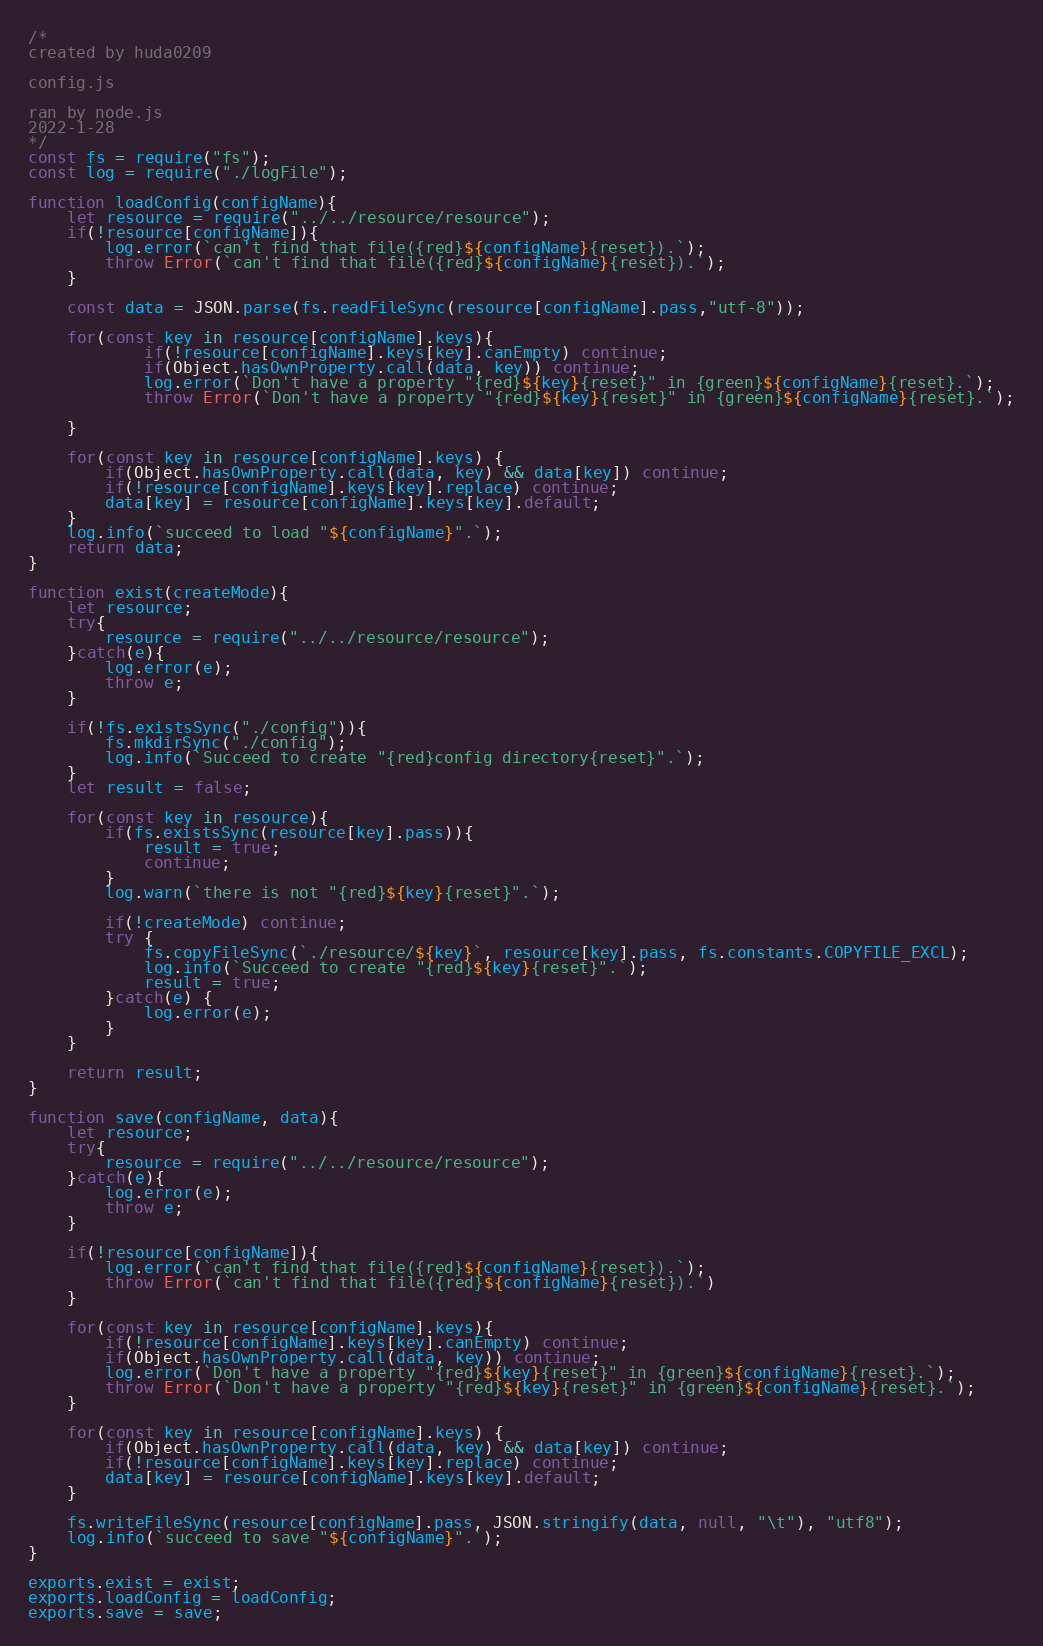Convert code to text. <code><loc_0><loc_0><loc_500><loc_500><_JavaScript_>/*
created by huda0209

config.js
 
ran by node.js
2022-1-28
*/
const fs = require("fs");
const log = require("./logFile");

function loadConfig(configName){
    let resource = require("../../resource/resource");
    if(!resource[configName]){
        log.error(`can't find that file({red}${configName}{reset}).`);
        throw Error(`can't find that file({red}${configName}{reset}).`);
    }

    const data = JSON.parse(fs.readFileSync(resource[configName].pass,"utf-8"));

    for(const key in resource[configName].keys){
            if(!resource[configName].keys[key].canEmpty) continue;
            if(Object.hasOwnProperty.call(data, key)) continue;
            log.error(`Don't have a property "{red}${key}{reset}" in {green}${configName}{reset}.`);
            throw Error(`Don't have a property "{red}${key}{reset}" in {green}${configName}{reset}.`);
        
    }

    for(const key in resource[configName].keys) {
        if(Object.hasOwnProperty.call(data, key) && data[key]) continue;
        if(!resource[configName].keys[key].replace) continue;
        data[key] = resource[configName].keys[key].default;
    }
    log.info(`succeed to load "${configName}".`);
    return data;
}

function exist(createMode){
    let resource;
    try{
        resource = require("../../resource/resource");
    }catch(e){
        log.error(e);
        throw e;
    }

    if(!fs.existsSync("./config")){
        fs.mkdirSync("./config");
        log.info(`Succeed to create "{red}config directory{reset}".`);
    }
    let result = false;

    for(const key in resource){
        if(fs.existsSync(resource[key].pass)){
            result = true;
            continue;
        }
        log.warn(`there is not "{red}${key}{reset}".`);

        if(!createMode) continue;
        try {
            fs.copyFileSync(`./resource/${key}`, resource[key].pass, fs.constants.COPYFILE_EXCL);
            log.info(`Succeed to create "{red}${key}{reset}".`);
            result = true;
        }catch(e) {
            log.error(e);
        }
    }

    return result;
}

function save(configName, data){
    let resource;
    try{
        resource = require("../../resource/resource");
    }catch(e){
        log.error(e);
        throw e;
    }

    if(!resource[configName]){
        log.error(`can't find that file({red}${configName}{reset}).`);
        throw Error(`can't find that file({red}${configName}{reset}).`)
    }
    
    for(const key in resource[configName].keys){
        if(!resource[configName].keys[key].canEmpty) continue;
        if(Object.hasOwnProperty.call(data, key)) continue;
        log.error(`Don't have a property "{red}${key}{reset}" in {green}${configName}{reset}.`);
        throw Error(`Don't have a property "{red}${key}{reset}" in {green}${configName}{reset}.`);
    }
    
    for(const key in resource[configName].keys) {
        if(Object.hasOwnProperty.call(data, key) && data[key]) continue;
        if(!resource[configName].keys[key].replace) continue;
        data[key] = resource[configName].keys[key].default;
    }
    
    fs.writeFileSync(resource[configName].pass, JSON.stringify(data, null, "\t"), "utf8");
    log.info(`succeed to save "${configName}".`);
}

exports.exist = exist;
exports.loadConfig = loadConfig;
exports.save = save;</code> 